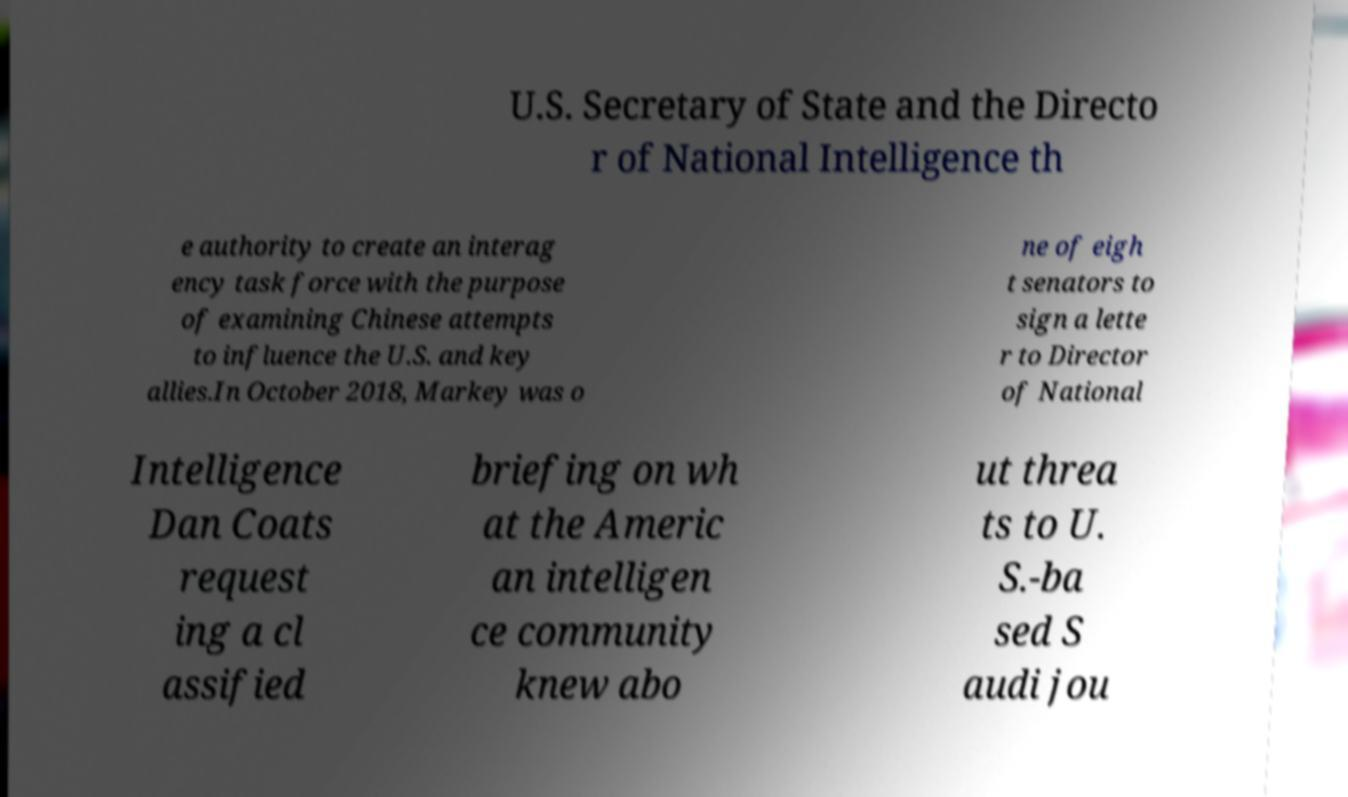I need the written content from this picture converted into text. Can you do that? U.S. Secretary of State and the Directo r of National Intelligence th e authority to create an interag ency task force with the purpose of examining Chinese attempts to influence the U.S. and key allies.In October 2018, Markey was o ne of eigh t senators to sign a lette r to Director of National Intelligence Dan Coats request ing a cl assified briefing on wh at the Americ an intelligen ce community knew abo ut threa ts to U. S.-ba sed S audi jou 